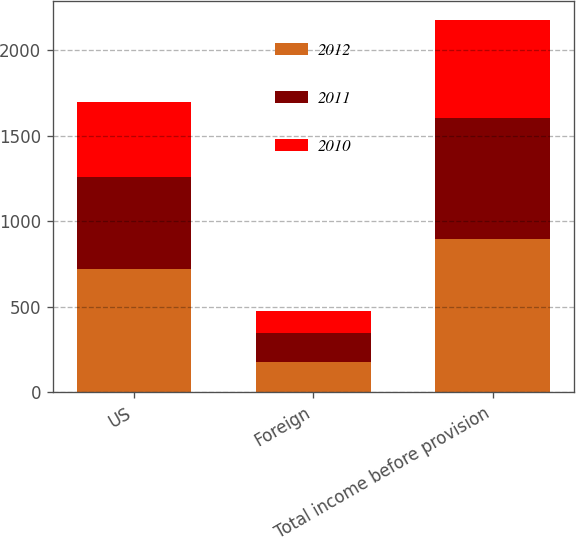Convert chart to OTSL. <chart><loc_0><loc_0><loc_500><loc_500><stacked_bar_chart><ecel><fcel>US<fcel>Foreign<fcel>Total income before provision<nl><fcel>2012<fcel>718.5<fcel>175.4<fcel>893.9<nl><fcel>2011<fcel>540.3<fcel>169.4<fcel>709.7<nl><fcel>2010<fcel>438.7<fcel>133.6<fcel>572.3<nl></chart> 